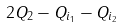Convert formula to latex. <formula><loc_0><loc_0><loc_500><loc_500>2 Q _ { 2 } - Q _ { i _ { 1 } } - Q _ { i _ { 2 } }</formula> 